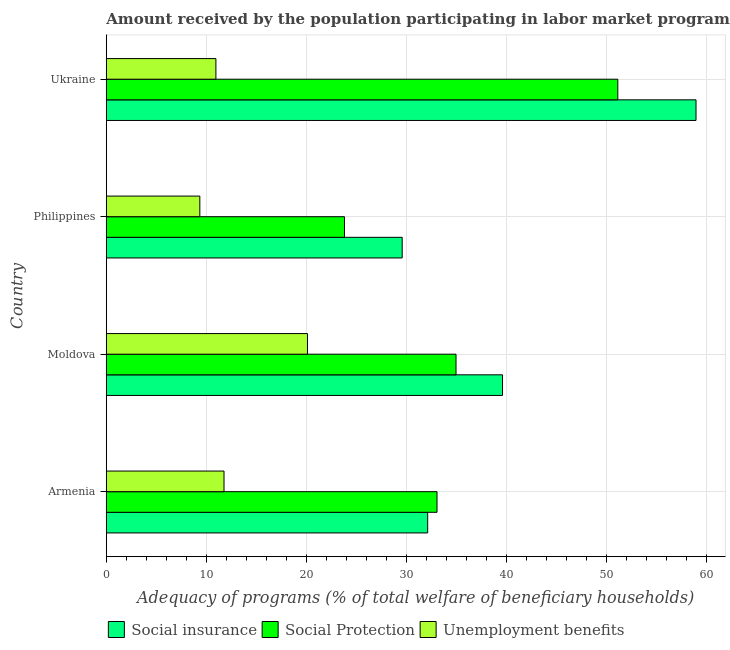How many groups of bars are there?
Ensure brevity in your answer.  4. Are the number of bars on each tick of the Y-axis equal?
Give a very brief answer. Yes. How many bars are there on the 3rd tick from the top?
Provide a succinct answer. 3. How many bars are there on the 1st tick from the bottom?
Offer a terse response. 3. What is the label of the 3rd group of bars from the top?
Your answer should be compact. Moldova. What is the amount received by the population participating in social protection programs in Armenia?
Offer a very short reply. 33.08. Across all countries, what is the maximum amount received by the population participating in unemployment benefits programs?
Offer a terse response. 20.12. Across all countries, what is the minimum amount received by the population participating in unemployment benefits programs?
Provide a short and direct response. 9.35. In which country was the amount received by the population participating in unemployment benefits programs maximum?
Your response must be concise. Moldova. In which country was the amount received by the population participating in social insurance programs minimum?
Your answer should be compact. Philippines. What is the total amount received by the population participating in social protection programs in the graph?
Make the answer very short. 143.06. What is the difference between the amount received by the population participating in social insurance programs in Moldova and that in Philippines?
Keep it short and to the point. 10.04. What is the difference between the amount received by the population participating in social protection programs in Philippines and the amount received by the population participating in unemployment benefits programs in Moldova?
Offer a terse response. 3.7. What is the average amount received by the population participating in social protection programs per country?
Ensure brevity in your answer.  35.77. What is the difference between the amount received by the population participating in social insurance programs and amount received by the population participating in unemployment benefits programs in Ukraine?
Your answer should be very brief. 48.03. What is the ratio of the amount received by the population participating in social insurance programs in Moldova to that in Philippines?
Your answer should be compact. 1.34. Is the difference between the amount received by the population participating in unemployment benefits programs in Armenia and Moldova greater than the difference between the amount received by the population participating in social insurance programs in Armenia and Moldova?
Your answer should be compact. No. What is the difference between the highest and the second highest amount received by the population participating in social insurance programs?
Your answer should be very brief. 19.36. What is the difference between the highest and the lowest amount received by the population participating in unemployment benefits programs?
Your answer should be very brief. 10.77. In how many countries, is the amount received by the population participating in social protection programs greater than the average amount received by the population participating in social protection programs taken over all countries?
Offer a terse response. 1. Is the sum of the amount received by the population participating in social protection programs in Armenia and Philippines greater than the maximum amount received by the population participating in unemployment benefits programs across all countries?
Keep it short and to the point. Yes. What does the 2nd bar from the top in Armenia represents?
Give a very brief answer. Social Protection. What does the 3rd bar from the bottom in Moldova represents?
Provide a succinct answer. Unemployment benefits. How many bars are there?
Ensure brevity in your answer.  12. Are all the bars in the graph horizontal?
Ensure brevity in your answer.  Yes. How many countries are there in the graph?
Your answer should be compact. 4. Are the values on the major ticks of X-axis written in scientific E-notation?
Give a very brief answer. No. Does the graph contain any zero values?
Your answer should be very brief. No. Does the graph contain grids?
Your answer should be very brief. Yes. How many legend labels are there?
Provide a succinct answer. 3. What is the title of the graph?
Provide a succinct answer. Amount received by the population participating in labor market programs in countries. Does "Coal" appear as one of the legend labels in the graph?
Provide a short and direct response. No. What is the label or title of the X-axis?
Your answer should be very brief. Adequacy of programs (% of total welfare of beneficiary households). What is the Adequacy of programs (% of total welfare of beneficiary households) of Social insurance in Armenia?
Make the answer very short. 32.15. What is the Adequacy of programs (% of total welfare of beneficiary households) of Social Protection in Armenia?
Ensure brevity in your answer.  33.08. What is the Adequacy of programs (% of total welfare of beneficiary households) of Unemployment benefits in Armenia?
Provide a short and direct response. 11.77. What is the Adequacy of programs (% of total welfare of beneficiary households) of Social insurance in Moldova?
Ensure brevity in your answer.  39.64. What is the Adequacy of programs (% of total welfare of beneficiary households) in Social Protection in Moldova?
Keep it short and to the point. 34.98. What is the Adequacy of programs (% of total welfare of beneficiary households) in Unemployment benefits in Moldova?
Ensure brevity in your answer.  20.12. What is the Adequacy of programs (% of total welfare of beneficiary households) in Social insurance in Philippines?
Provide a short and direct response. 29.6. What is the Adequacy of programs (% of total welfare of beneficiary households) of Social Protection in Philippines?
Your answer should be very brief. 23.82. What is the Adequacy of programs (% of total welfare of beneficiary households) in Unemployment benefits in Philippines?
Offer a very short reply. 9.35. What is the Adequacy of programs (% of total welfare of beneficiary households) of Social insurance in Ukraine?
Provide a succinct answer. 58.99. What is the Adequacy of programs (% of total welfare of beneficiary households) of Social Protection in Ukraine?
Offer a terse response. 51.17. What is the Adequacy of programs (% of total welfare of beneficiary households) of Unemployment benefits in Ukraine?
Your answer should be compact. 10.96. Across all countries, what is the maximum Adequacy of programs (% of total welfare of beneficiary households) in Social insurance?
Provide a short and direct response. 58.99. Across all countries, what is the maximum Adequacy of programs (% of total welfare of beneficiary households) of Social Protection?
Offer a very short reply. 51.17. Across all countries, what is the maximum Adequacy of programs (% of total welfare of beneficiary households) of Unemployment benefits?
Your response must be concise. 20.12. Across all countries, what is the minimum Adequacy of programs (% of total welfare of beneficiary households) of Social insurance?
Your response must be concise. 29.6. Across all countries, what is the minimum Adequacy of programs (% of total welfare of beneficiary households) in Social Protection?
Your response must be concise. 23.82. Across all countries, what is the minimum Adequacy of programs (% of total welfare of beneficiary households) of Unemployment benefits?
Your answer should be compact. 9.35. What is the total Adequacy of programs (% of total welfare of beneficiary households) in Social insurance in the graph?
Make the answer very short. 160.38. What is the total Adequacy of programs (% of total welfare of beneficiary households) in Social Protection in the graph?
Keep it short and to the point. 143.06. What is the total Adequacy of programs (% of total welfare of beneficiary households) in Unemployment benefits in the graph?
Your response must be concise. 52.21. What is the difference between the Adequacy of programs (% of total welfare of beneficiary households) in Social insurance in Armenia and that in Moldova?
Keep it short and to the point. -7.49. What is the difference between the Adequacy of programs (% of total welfare of beneficiary households) in Social Protection in Armenia and that in Moldova?
Ensure brevity in your answer.  -1.9. What is the difference between the Adequacy of programs (% of total welfare of beneficiary households) in Unemployment benefits in Armenia and that in Moldova?
Give a very brief answer. -8.35. What is the difference between the Adequacy of programs (% of total welfare of beneficiary households) in Social insurance in Armenia and that in Philippines?
Keep it short and to the point. 2.55. What is the difference between the Adequacy of programs (% of total welfare of beneficiary households) in Social Protection in Armenia and that in Philippines?
Ensure brevity in your answer.  9.26. What is the difference between the Adequacy of programs (% of total welfare of beneficiary households) in Unemployment benefits in Armenia and that in Philippines?
Provide a short and direct response. 2.42. What is the difference between the Adequacy of programs (% of total welfare of beneficiary households) in Social insurance in Armenia and that in Ukraine?
Offer a terse response. -26.85. What is the difference between the Adequacy of programs (% of total welfare of beneficiary households) of Social Protection in Armenia and that in Ukraine?
Offer a terse response. -18.09. What is the difference between the Adequacy of programs (% of total welfare of beneficiary households) of Unemployment benefits in Armenia and that in Ukraine?
Make the answer very short. 0.81. What is the difference between the Adequacy of programs (% of total welfare of beneficiary households) in Social insurance in Moldova and that in Philippines?
Give a very brief answer. 10.04. What is the difference between the Adequacy of programs (% of total welfare of beneficiary households) of Social Protection in Moldova and that in Philippines?
Your response must be concise. 11.16. What is the difference between the Adequacy of programs (% of total welfare of beneficiary households) of Unemployment benefits in Moldova and that in Philippines?
Your response must be concise. 10.77. What is the difference between the Adequacy of programs (% of total welfare of beneficiary households) in Social insurance in Moldova and that in Ukraine?
Your answer should be very brief. -19.36. What is the difference between the Adequacy of programs (% of total welfare of beneficiary households) in Social Protection in Moldova and that in Ukraine?
Provide a succinct answer. -16.19. What is the difference between the Adequacy of programs (% of total welfare of beneficiary households) of Unemployment benefits in Moldova and that in Ukraine?
Provide a succinct answer. 9.16. What is the difference between the Adequacy of programs (% of total welfare of beneficiary households) of Social insurance in Philippines and that in Ukraine?
Your answer should be compact. -29.4. What is the difference between the Adequacy of programs (% of total welfare of beneficiary households) in Social Protection in Philippines and that in Ukraine?
Give a very brief answer. -27.35. What is the difference between the Adequacy of programs (% of total welfare of beneficiary households) in Unemployment benefits in Philippines and that in Ukraine?
Provide a succinct answer. -1.61. What is the difference between the Adequacy of programs (% of total welfare of beneficiary households) of Social insurance in Armenia and the Adequacy of programs (% of total welfare of beneficiary households) of Social Protection in Moldova?
Your answer should be compact. -2.84. What is the difference between the Adequacy of programs (% of total welfare of beneficiary households) in Social insurance in Armenia and the Adequacy of programs (% of total welfare of beneficiary households) in Unemployment benefits in Moldova?
Provide a short and direct response. 12.03. What is the difference between the Adequacy of programs (% of total welfare of beneficiary households) in Social Protection in Armenia and the Adequacy of programs (% of total welfare of beneficiary households) in Unemployment benefits in Moldova?
Keep it short and to the point. 12.96. What is the difference between the Adequacy of programs (% of total welfare of beneficiary households) in Social insurance in Armenia and the Adequacy of programs (% of total welfare of beneficiary households) in Social Protection in Philippines?
Provide a succinct answer. 8.32. What is the difference between the Adequacy of programs (% of total welfare of beneficiary households) of Social insurance in Armenia and the Adequacy of programs (% of total welfare of beneficiary households) of Unemployment benefits in Philippines?
Offer a terse response. 22.79. What is the difference between the Adequacy of programs (% of total welfare of beneficiary households) in Social Protection in Armenia and the Adequacy of programs (% of total welfare of beneficiary households) in Unemployment benefits in Philippines?
Provide a succinct answer. 23.73. What is the difference between the Adequacy of programs (% of total welfare of beneficiary households) of Social insurance in Armenia and the Adequacy of programs (% of total welfare of beneficiary households) of Social Protection in Ukraine?
Offer a terse response. -19.02. What is the difference between the Adequacy of programs (% of total welfare of beneficiary households) in Social insurance in Armenia and the Adequacy of programs (% of total welfare of beneficiary households) in Unemployment benefits in Ukraine?
Give a very brief answer. 21.19. What is the difference between the Adequacy of programs (% of total welfare of beneficiary households) in Social Protection in Armenia and the Adequacy of programs (% of total welfare of beneficiary households) in Unemployment benefits in Ukraine?
Keep it short and to the point. 22.12. What is the difference between the Adequacy of programs (% of total welfare of beneficiary households) in Social insurance in Moldova and the Adequacy of programs (% of total welfare of beneficiary households) in Social Protection in Philippines?
Offer a very short reply. 15.81. What is the difference between the Adequacy of programs (% of total welfare of beneficiary households) in Social insurance in Moldova and the Adequacy of programs (% of total welfare of beneficiary households) in Unemployment benefits in Philippines?
Your answer should be very brief. 30.28. What is the difference between the Adequacy of programs (% of total welfare of beneficiary households) in Social Protection in Moldova and the Adequacy of programs (% of total welfare of beneficiary households) in Unemployment benefits in Philippines?
Make the answer very short. 25.63. What is the difference between the Adequacy of programs (% of total welfare of beneficiary households) in Social insurance in Moldova and the Adequacy of programs (% of total welfare of beneficiary households) in Social Protection in Ukraine?
Ensure brevity in your answer.  -11.53. What is the difference between the Adequacy of programs (% of total welfare of beneficiary households) of Social insurance in Moldova and the Adequacy of programs (% of total welfare of beneficiary households) of Unemployment benefits in Ukraine?
Your response must be concise. 28.68. What is the difference between the Adequacy of programs (% of total welfare of beneficiary households) in Social Protection in Moldova and the Adequacy of programs (% of total welfare of beneficiary households) in Unemployment benefits in Ukraine?
Ensure brevity in your answer.  24.02. What is the difference between the Adequacy of programs (% of total welfare of beneficiary households) of Social insurance in Philippines and the Adequacy of programs (% of total welfare of beneficiary households) of Social Protection in Ukraine?
Keep it short and to the point. -21.57. What is the difference between the Adequacy of programs (% of total welfare of beneficiary households) of Social insurance in Philippines and the Adequacy of programs (% of total welfare of beneficiary households) of Unemployment benefits in Ukraine?
Your answer should be compact. 18.64. What is the difference between the Adequacy of programs (% of total welfare of beneficiary households) of Social Protection in Philippines and the Adequacy of programs (% of total welfare of beneficiary households) of Unemployment benefits in Ukraine?
Your answer should be very brief. 12.86. What is the average Adequacy of programs (% of total welfare of beneficiary households) in Social insurance per country?
Your response must be concise. 40.09. What is the average Adequacy of programs (% of total welfare of beneficiary households) of Social Protection per country?
Offer a terse response. 35.77. What is the average Adequacy of programs (% of total welfare of beneficiary households) of Unemployment benefits per country?
Offer a very short reply. 13.05. What is the difference between the Adequacy of programs (% of total welfare of beneficiary households) in Social insurance and Adequacy of programs (% of total welfare of beneficiary households) in Social Protection in Armenia?
Ensure brevity in your answer.  -0.94. What is the difference between the Adequacy of programs (% of total welfare of beneficiary households) in Social insurance and Adequacy of programs (% of total welfare of beneficiary households) in Unemployment benefits in Armenia?
Give a very brief answer. 20.37. What is the difference between the Adequacy of programs (% of total welfare of beneficiary households) in Social Protection and Adequacy of programs (% of total welfare of beneficiary households) in Unemployment benefits in Armenia?
Provide a succinct answer. 21.31. What is the difference between the Adequacy of programs (% of total welfare of beneficiary households) in Social insurance and Adequacy of programs (% of total welfare of beneficiary households) in Social Protection in Moldova?
Provide a short and direct response. 4.65. What is the difference between the Adequacy of programs (% of total welfare of beneficiary households) of Social insurance and Adequacy of programs (% of total welfare of beneficiary households) of Unemployment benefits in Moldova?
Keep it short and to the point. 19.52. What is the difference between the Adequacy of programs (% of total welfare of beneficiary households) of Social Protection and Adequacy of programs (% of total welfare of beneficiary households) of Unemployment benefits in Moldova?
Keep it short and to the point. 14.86. What is the difference between the Adequacy of programs (% of total welfare of beneficiary households) of Social insurance and Adequacy of programs (% of total welfare of beneficiary households) of Social Protection in Philippines?
Provide a succinct answer. 5.78. What is the difference between the Adequacy of programs (% of total welfare of beneficiary households) in Social insurance and Adequacy of programs (% of total welfare of beneficiary households) in Unemployment benefits in Philippines?
Offer a very short reply. 20.25. What is the difference between the Adequacy of programs (% of total welfare of beneficiary households) in Social Protection and Adequacy of programs (% of total welfare of beneficiary households) in Unemployment benefits in Philippines?
Offer a terse response. 14.47. What is the difference between the Adequacy of programs (% of total welfare of beneficiary households) of Social insurance and Adequacy of programs (% of total welfare of beneficiary households) of Social Protection in Ukraine?
Give a very brief answer. 7.82. What is the difference between the Adequacy of programs (% of total welfare of beneficiary households) in Social insurance and Adequacy of programs (% of total welfare of beneficiary households) in Unemployment benefits in Ukraine?
Provide a short and direct response. 48.03. What is the difference between the Adequacy of programs (% of total welfare of beneficiary households) in Social Protection and Adequacy of programs (% of total welfare of beneficiary households) in Unemployment benefits in Ukraine?
Your answer should be very brief. 40.21. What is the ratio of the Adequacy of programs (% of total welfare of beneficiary households) in Social insurance in Armenia to that in Moldova?
Offer a terse response. 0.81. What is the ratio of the Adequacy of programs (% of total welfare of beneficiary households) in Social Protection in Armenia to that in Moldova?
Keep it short and to the point. 0.95. What is the ratio of the Adequacy of programs (% of total welfare of beneficiary households) of Unemployment benefits in Armenia to that in Moldova?
Ensure brevity in your answer.  0.59. What is the ratio of the Adequacy of programs (% of total welfare of beneficiary households) of Social insurance in Armenia to that in Philippines?
Make the answer very short. 1.09. What is the ratio of the Adequacy of programs (% of total welfare of beneficiary households) in Social Protection in Armenia to that in Philippines?
Make the answer very short. 1.39. What is the ratio of the Adequacy of programs (% of total welfare of beneficiary households) of Unemployment benefits in Armenia to that in Philippines?
Your answer should be compact. 1.26. What is the ratio of the Adequacy of programs (% of total welfare of beneficiary households) in Social insurance in Armenia to that in Ukraine?
Provide a succinct answer. 0.54. What is the ratio of the Adequacy of programs (% of total welfare of beneficiary households) of Social Protection in Armenia to that in Ukraine?
Provide a succinct answer. 0.65. What is the ratio of the Adequacy of programs (% of total welfare of beneficiary households) in Unemployment benefits in Armenia to that in Ukraine?
Give a very brief answer. 1.07. What is the ratio of the Adequacy of programs (% of total welfare of beneficiary households) in Social insurance in Moldova to that in Philippines?
Ensure brevity in your answer.  1.34. What is the ratio of the Adequacy of programs (% of total welfare of beneficiary households) of Social Protection in Moldova to that in Philippines?
Provide a short and direct response. 1.47. What is the ratio of the Adequacy of programs (% of total welfare of beneficiary households) in Unemployment benefits in Moldova to that in Philippines?
Your answer should be very brief. 2.15. What is the ratio of the Adequacy of programs (% of total welfare of beneficiary households) in Social insurance in Moldova to that in Ukraine?
Provide a short and direct response. 0.67. What is the ratio of the Adequacy of programs (% of total welfare of beneficiary households) of Social Protection in Moldova to that in Ukraine?
Provide a short and direct response. 0.68. What is the ratio of the Adequacy of programs (% of total welfare of beneficiary households) in Unemployment benefits in Moldova to that in Ukraine?
Your response must be concise. 1.84. What is the ratio of the Adequacy of programs (% of total welfare of beneficiary households) in Social insurance in Philippines to that in Ukraine?
Offer a terse response. 0.5. What is the ratio of the Adequacy of programs (% of total welfare of beneficiary households) of Social Protection in Philippines to that in Ukraine?
Give a very brief answer. 0.47. What is the ratio of the Adequacy of programs (% of total welfare of beneficiary households) of Unemployment benefits in Philippines to that in Ukraine?
Offer a terse response. 0.85. What is the difference between the highest and the second highest Adequacy of programs (% of total welfare of beneficiary households) in Social insurance?
Keep it short and to the point. 19.36. What is the difference between the highest and the second highest Adequacy of programs (% of total welfare of beneficiary households) in Social Protection?
Give a very brief answer. 16.19. What is the difference between the highest and the second highest Adequacy of programs (% of total welfare of beneficiary households) in Unemployment benefits?
Make the answer very short. 8.35. What is the difference between the highest and the lowest Adequacy of programs (% of total welfare of beneficiary households) of Social insurance?
Your answer should be compact. 29.4. What is the difference between the highest and the lowest Adequacy of programs (% of total welfare of beneficiary households) of Social Protection?
Offer a very short reply. 27.35. What is the difference between the highest and the lowest Adequacy of programs (% of total welfare of beneficiary households) of Unemployment benefits?
Offer a terse response. 10.77. 